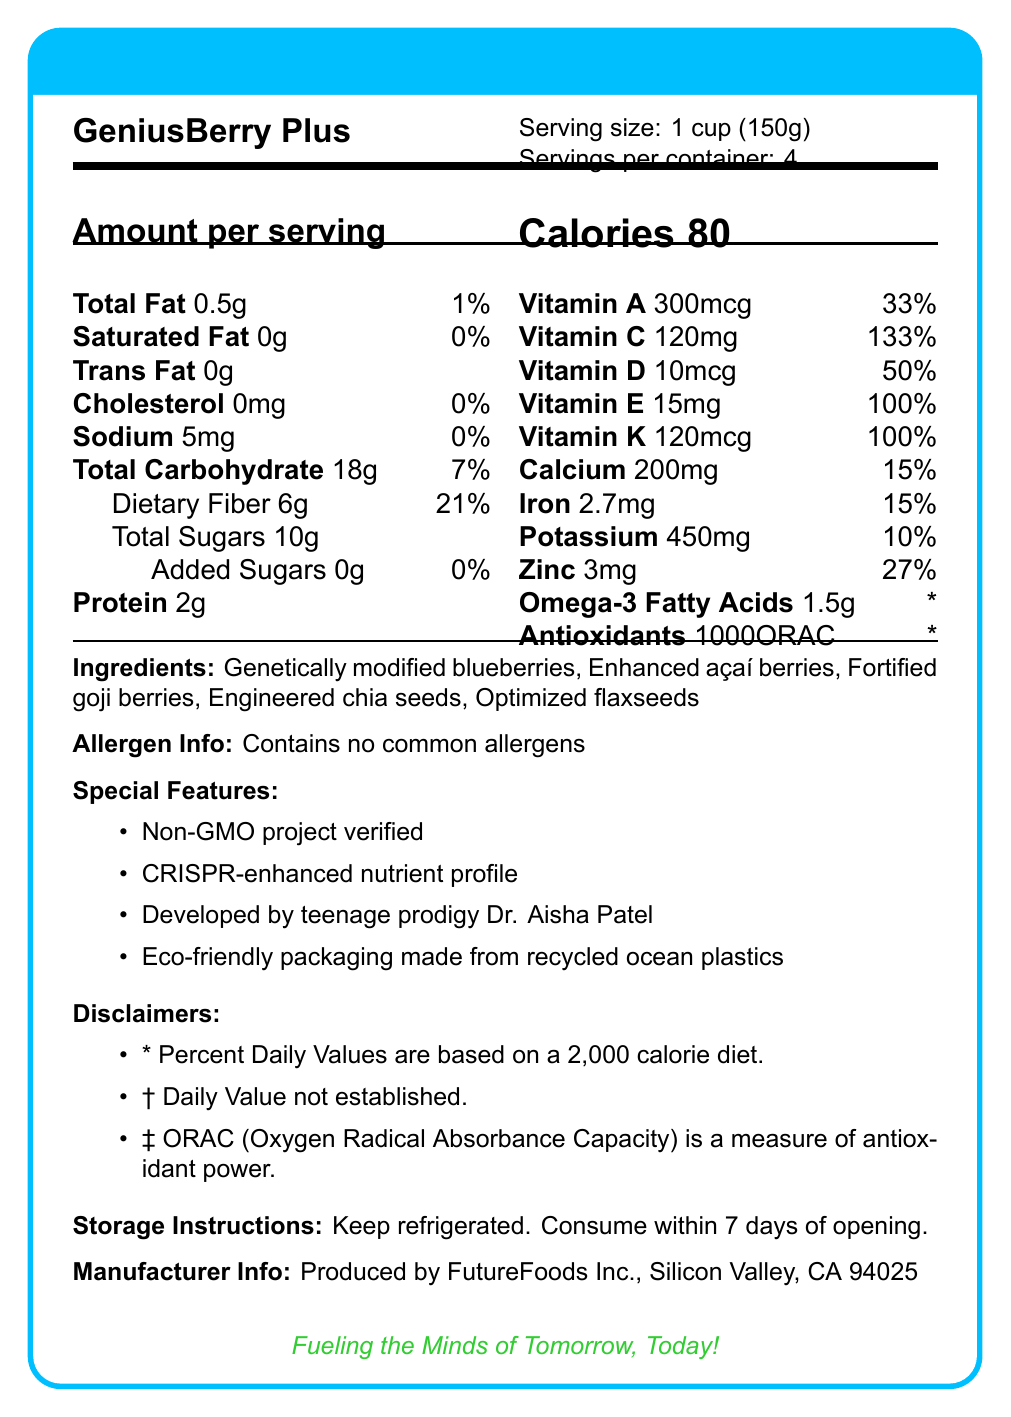what is the serving size of GeniusBerry Plus? The serving size is explicitly stated as "1 cup (150g)" in the document.
Answer: 1 cup (150g) how many calories are in one serving of GeniusBerry Plus? The document states that each serving contains 80 calories.
Answer: 80 how much dietary fiber does one serving contain, and what is its percent daily value? The document indicates that each serving has 6g of dietary fiber, which is 21% of the daily value.
Answer: 6g, 21% what are the three ingredients in GeniusBerry Plus that start with the letter "E"? The ingredients list highlights "Enhanced açaí berries" and "Engineered chia seeds" while the special features mention "Eco-friendly packaging made from recycled ocean plastics".
Answer: Enhanced açaí berries, Engineered chia seeds, Eco-friendly packaging made from recycled ocean plastics who developed GeniusBerry Plus? The special features section mentions that GeniusBerry Plus was developed by teenage prodigy Dr. Aisha Patel.
Answer: Teenage prodigy Dr. Aisha Patel what is the percent daily value of vitamin C in one serving? The document lists the percent daily value of vitamin C as 133%.
Answer: 133% which of these vitamins have a percent daily value of 100%? A. Vitamin A B. Vitamin C C. Vitamin E D. Vitamin K The document shows that both Vitamin E and Vitamin K have a percent daily value of 100%.
Answer: C and D how much calcium does one serving of GeniusBerry Plus contain? A. 100mg B. 150mg C. 200mg D. 250mg The amount of calcium per serving is listed as 200mg.
Answer: C. 200mg does GeniusBerry Plus contain any common allergens? The allergen information states that it contains no common allergens.
Answer: No summarize the main features of GeniusBerry Plus from its Nutrition Facts Label. This summary encapsulates the major aspects of the product including nutritional content, special features, development, and storage instructions.
Answer: GeniusBerry Plus is a genetically modified superfood with a serving size of 1 cup (150g) and contains 80 calories per serving. It is high in dietary fiber (6g, 21% daily value) and vitamins such as Vitamin C (120mg, 133% daily value) and Vitamin E (15mg, 100% daily value). The product contains no common allergens, comes with CRISPR-enhanced nutrient profile, and eco-friendly packaging. It was developed by Dr. Aisha Patel and has a variety of ingredients like genetically modified blueberries and fortified goji berries. Storage instructions recommend refrigeration and consuming within 7 days of opening. what is the ORAC value, and what does it represent? The ORAC value is 1000, and the disclaimer in the document mentions that ORAC is a measure of antioxidant power.
Answer: 1000ORAC, measure of antioxidant power how much protein is in one serving of GeniusBerry Plus? The document lists the protein content per serving as 2g.
Answer: 2g what does the storage instruction recommend for GeniusBerry Plus? The storage instructions clearly state to keep the product refrigerated and to consume it within 7 days of opening.
Answer: Keep refrigerated. Consume within 7 days of opening. how many servings are there per container? The document states there are 4 servings per container.
Answer: 4 what is the purpose of mentioning CRISPR in this document? The special features section mentions "CRISPR-enhanced nutrient profile" indicating that CRISPR was used to enhance the nutritional content.
Answer: To highlight the enhanced nutrient profile achieved through CRISPR technology. what is the company that produces GeniusBerry Plus? The manufacturer information lists FutureFoods Inc. as the producer, located in Silicon Valley, CA 94025.
Answer: FutureFoods Inc., Silicon Valley, CA 94025 how much sodium is there per serving, and what is its percent daily value? The sodium content per serving is listed as 5mg, with a 0% daily value.
Answer: 5mg, 0% what is the daily value of Omega-3 Fatty Acids in GeniusBerry Plus? The document contains an asterisk (*) indicating that the daily value for Omega-3 Fatty Acids has not been established.
Answer: Cannot be determined 